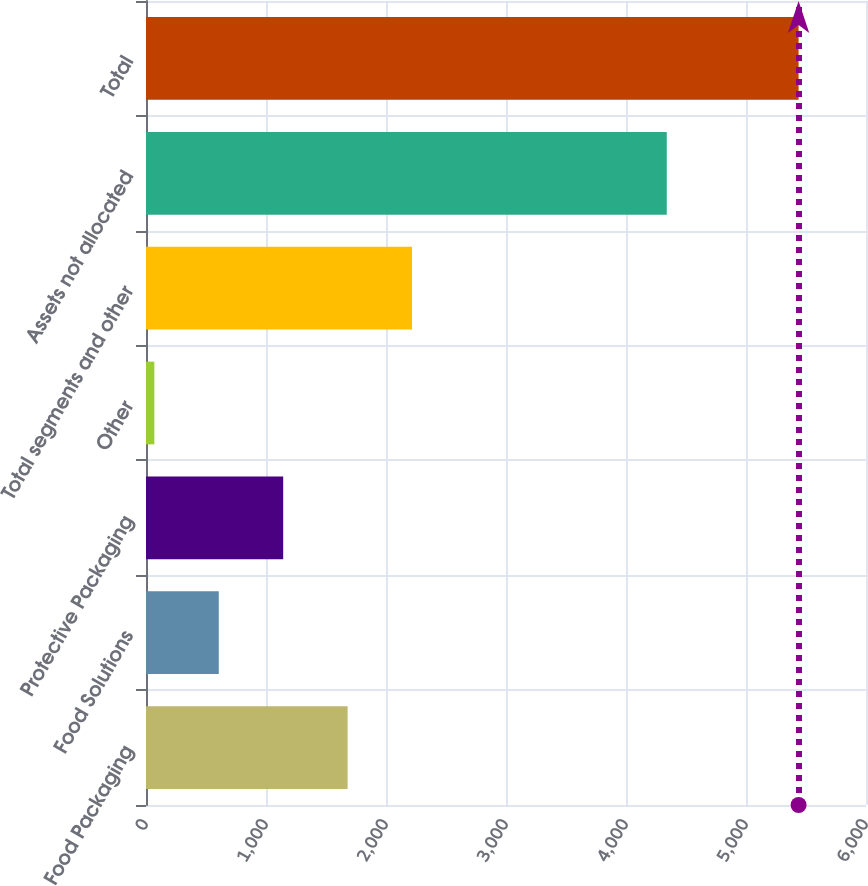Convert chart to OTSL. <chart><loc_0><loc_0><loc_500><loc_500><bar_chart><fcel>Food Packaging<fcel>Food Solutions<fcel>Protective Packaging<fcel>Other<fcel>Total segments and other<fcel>Assets not allocated<fcel>Total<nl><fcel>1680.14<fcel>606.38<fcel>1143.26<fcel>69.5<fcel>2217.02<fcel>4339.8<fcel>5438.3<nl></chart> 